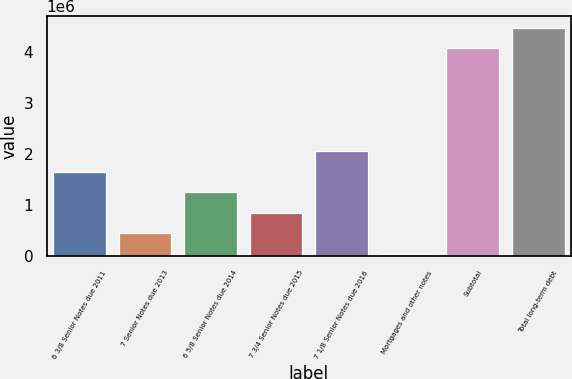Convert chart. <chart><loc_0><loc_0><loc_500><loc_500><bar_chart><fcel>6 3/8 Senior Notes due 2011<fcel>7 Senior Notes due 2013<fcel>6 5/8 Senior Notes due 2014<fcel>7 3/4 Senior Notes due 2015<fcel>7 1/8 Senior Notes due 2016<fcel>Mortgages and other notes<fcel>Subtotal<fcel>Total long-term debt<nl><fcel>1.65779e+06<fcel>449107<fcel>1.2549e+06<fcel>852003<fcel>2.06069e+06<fcel>46211<fcel>4.07517e+06<fcel>4.47806e+06<nl></chart> 